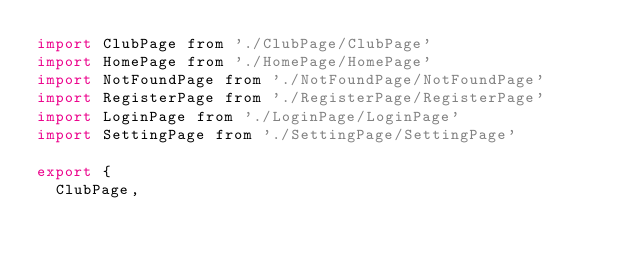Convert code to text. <code><loc_0><loc_0><loc_500><loc_500><_JavaScript_>import ClubPage from './ClubPage/ClubPage'
import HomePage from './HomePage/HomePage'
import NotFoundPage from './NotFoundPage/NotFoundPage'
import RegisterPage from './RegisterPage/RegisterPage'
import LoginPage from './LoginPage/LoginPage'
import SettingPage from './SettingPage/SettingPage'

export {
  ClubPage,</code> 